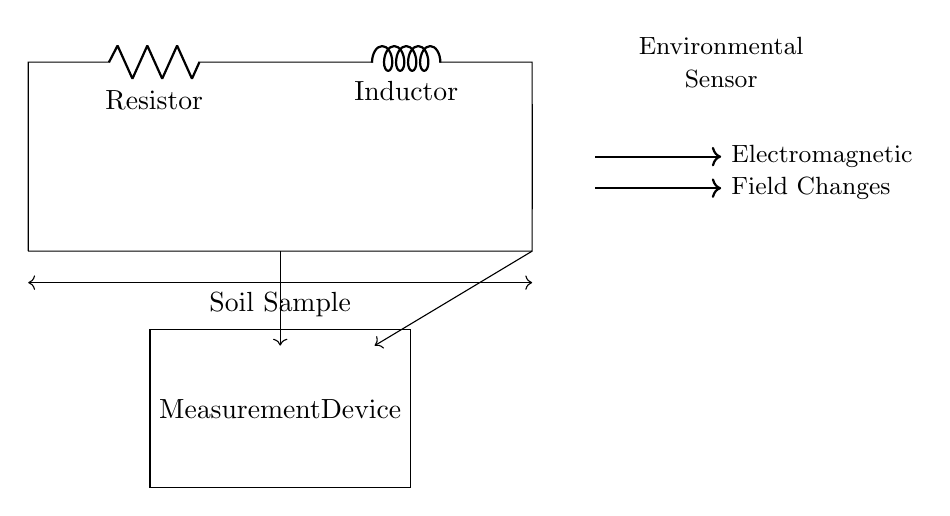What are the components in this circuit? The components are a resistor and an inductor, which are shown in the diagram as labeled.
Answer: Resistor, Inductor What connects the resistor and inductor in this circuit? The resistor and inductor are connected in series, meaning the current flows through the resistor and then through the inductor without any branching.
Answer: Series connection What does the arrow pointing towards the soil sample indicate? The arrow signifies the flow of electromagnetic fields interacting with the soil sample, suggesting that the circuit is designed to measure these changes.
Answer: Electromagnetic field How does the measurement device relate to the circuit? The measurement device is connected to the circuit, specifically measuring the output or conditions after the inductor, indicating that it monitors the changes occurring in the soil sample.
Answer: Monitors changes Why might a resistor be used in this circuit? A resistor is typically used to limit current, provide stability, and influence the overall impedance of the circuit, which is crucial for obtaining accurate measurements of electromagnetic changes.
Answer: To limit current What is the purpose of the inductor in this circuit? The inductor is used to store energy in a magnetic field and is key in measuring inductive reactance, which helps detect subtle changes in electromagnetic properties of the soil.
Answer: To store energy and measure reactance 